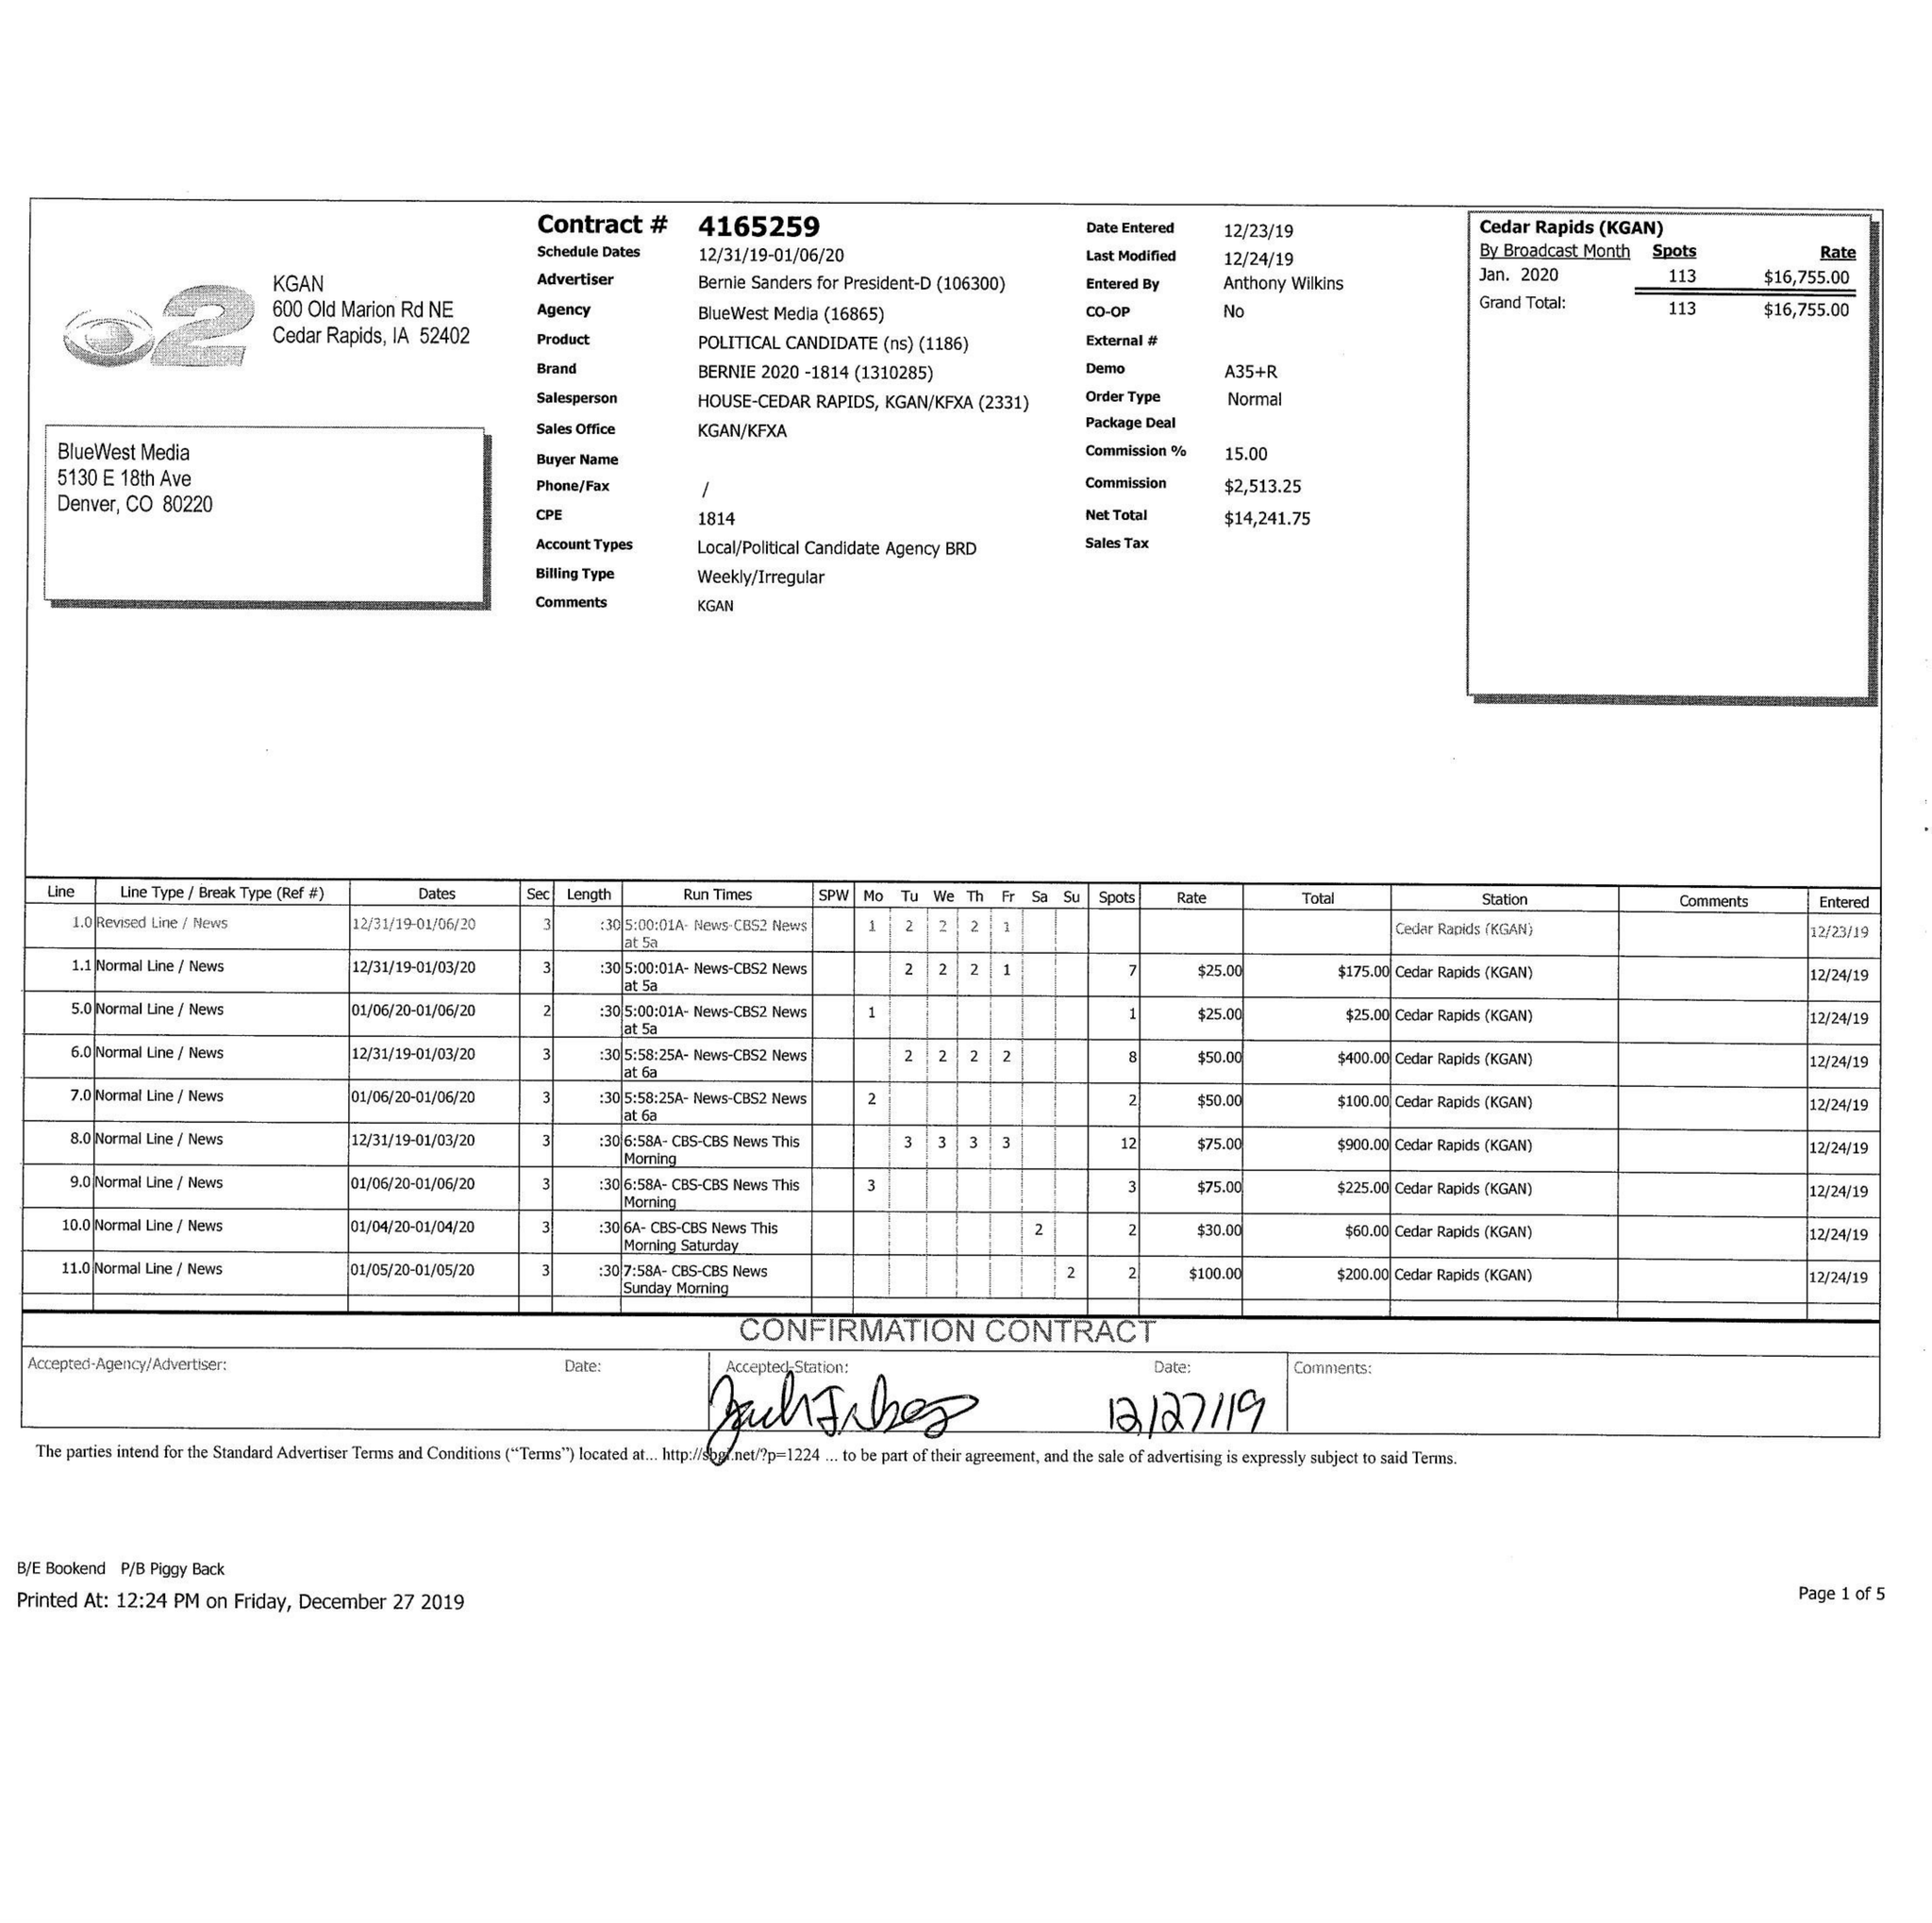What is the value for the flight_to?
Answer the question using a single word or phrase. 01/06/20 